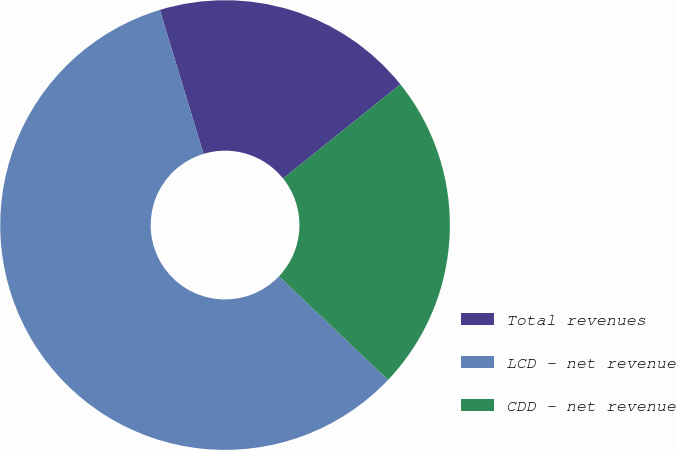Convert chart to OTSL. <chart><loc_0><loc_0><loc_500><loc_500><pie_chart><fcel>Total revenues<fcel>LCD - net revenue<fcel>CDD - net revenue<nl><fcel>18.92%<fcel>58.22%<fcel>22.85%<nl></chart> 